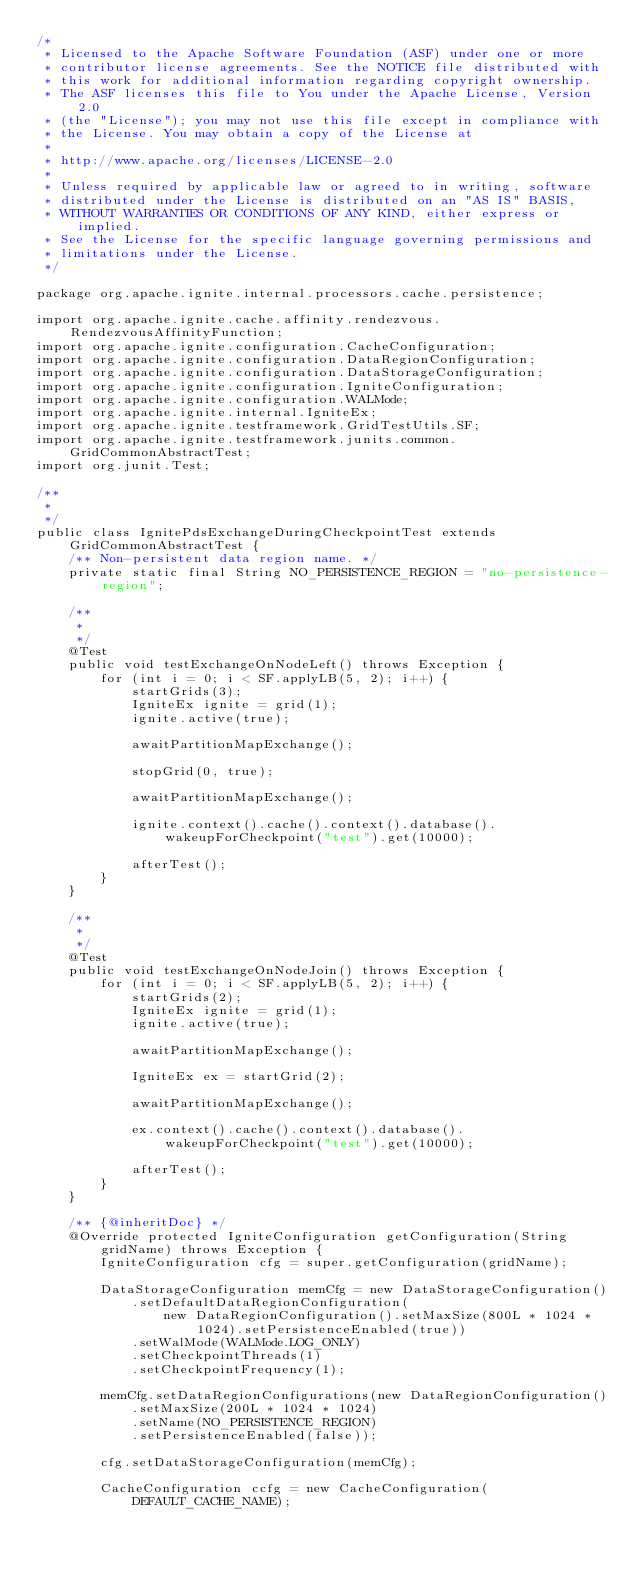Convert code to text. <code><loc_0><loc_0><loc_500><loc_500><_Java_>/*
 * Licensed to the Apache Software Foundation (ASF) under one or more
 * contributor license agreements. See the NOTICE file distributed with
 * this work for additional information regarding copyright ownership.
 * The ASF licenses this file to You under the Apache License, Version 2.0
 * (the "License"); you may not use this file except in compliance with
 * the License. You may obtain a copy of the License at
 *
 * http://www.apache.org/licenses/LICENSE-2.0
 *
 * Unless required by applicable law or agreed to in writing, software
 * distributed under the License is distributed on an "AS IS" BASIS,
 * WITHOUT WARRANTIES OR CONDITIONS OF ANY KIND, either express or implied.
 * See the License for the specific language governing permissions and
 * limitations under the License.
 */

package org.apache.ignite.internal.processors.cache.persistence;

import org.apache.ignite.cache.affinity.rendezvous.RendezvousAffinityFunction;
import org.apache.ignite.configuration.CacheConfiguration;
import org.apache.ignite.configuration.DataRegionConfiguration;
import org.apache.ignite.configuration.DataStorageConfiguration;
import org.apache.ignite.configuration.IgniteConfiguration;
import org.apache.ignite.configuration.WALMode;
import org.apache.ignite.internal.IgniteEx;
import org.apache.ignite.testframework.GridTestUtils.SF;
import org.apache.ignite.testframework.junits.common.GridCommonAbstractTest;
import org.junit.Test;

/**
 *
 */
public class IgnitePdsExchangeDuringCheckpointTest extends GridCommonAbstractTest {
    /** Non-persistent data region name. */
    private static final String NO_PERSISTENCE_REGION = "no-persistence-region";

    /**
     *
     */
    @Test
    public void testExchangeOnNodeLeft() throws Exception {
        for (int i = 0; i < SF.applyLB(5, 2); i++) {
            startGrids(3);
            IgniteEx ignite = grid(1);
            ignite.active(true);

            awaitPartitionMapExchange();

            stopGrid(0, true);

            awaitPartitionMapExchange();

            ignite.context().cache().context().database().wakeupForCheckpoint("test").get(10000);

            afterTest();
        }
    }

    /**
     *
     */
    @Test
    public void testExchangeOnNodeJoin() throws Exception {
        for (int i = 0; i < SF.applyLB(5, 2); i++) {
            startGrids(2);
            IgniteEx ignite = grid(1);
            ignite.active(true);

            awaitPartitionMapExchange();

            IgniteEx ex = startGrid(2);

            awaitPartitionMapExchange();

            ex.context().cache().context().database().wakeupForCheckpoint("test").get(10000);

            afterTest();
        }
    }

    /** {@inheritDoc} */
    @Override protected IgniteConfiguration getConfiguration(String gridName) throws Exception {
        IgniteConfiguration cfg = super.getConfiguration(gridName);

        DataStorageConfiguration memCfg = new DataStorageConfiguration()
            .setDefaultDataRegionConfiguration(
                new DataRegionConfiguration().setMaxSize(800L * 1024 * 1024).setPersistenceEnabled(true))
            .setWalMode(WALMode.LOG_ONLY)
            .setCheckpointThreads(1)
            .setCheckpointFrequency(1);

        memCfg.setDataRegionConfigurations(new DataRegionConfiguration()
            .setMaxSize(200L * 1024 * 1024)
            .setName(NO_PERSISTENCE_REGION)
            .setPersistenceEnabled(false));

        cfg.setDataStorageConfiguration(memCfg);

        CacheConfiguration ccfg = new CacheConfiguration(DEFAULT_CACHE_NAME);
</code> 